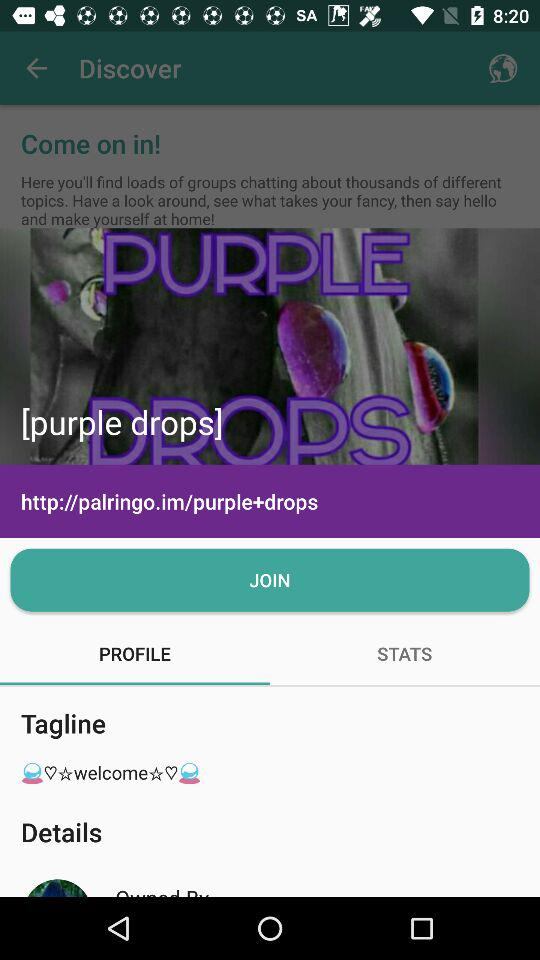What's the URL? The URL is "http://palringo.im/purple+drops". 